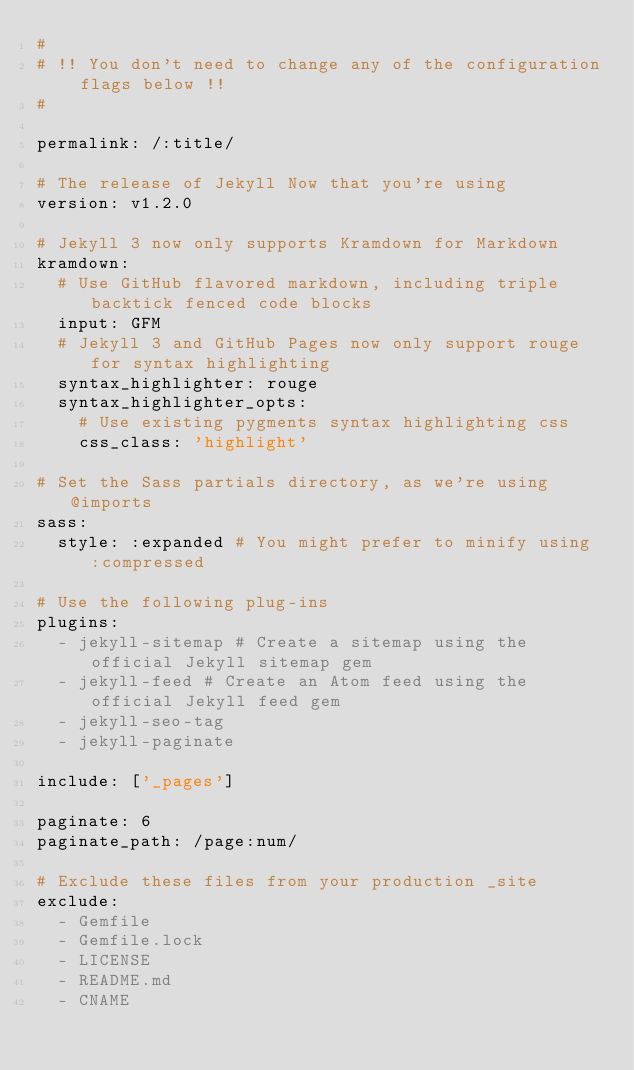Convert code to text. <code><loc_0><loc_0><loc_500><loc_500><_YAML_>#
# !! You don't need to change any of the configuration flags below !!
#

permalink: /:title/

# The release of Jekyll Now that you're using
version: v1.2.0

# Jekyll 3 now only supports Kramdown for Markdown
kramdown:
  # Use GitHub flavored markdown, including triple backtick fenced code blocks
  input: GFM
  # Jekyll 3 and GitHub Pages now only support rouge for syntax highlighting
  syntax_highlighter: rouge
  syntax_highlighter_opts:
    # Use existing pygments syntax highlighting css
    css_class: 'highlight'

# Set the Sass partials directory, as we're using @imports
sass:
  style: :expanded # You might prefer to minify using :compressed

# Use the following plug-ins
plugins:
  - jekyll-sitemap # Create a sitemap using the official Jekyll sitemap gem
  - jekyll-feed # Create an Atom feed using the official Jekyll feed gem
  - jekyll-seo-tag
  - jekyll-paginate

include: ['_pages']

paginate: 6
paginate_path: /page:num/

# Exclude these files from your production _site
exclude:
  - Gemfile
  - Gemfile.lock
  - LICENSE
  - README.md
  - CNAME

</code> 